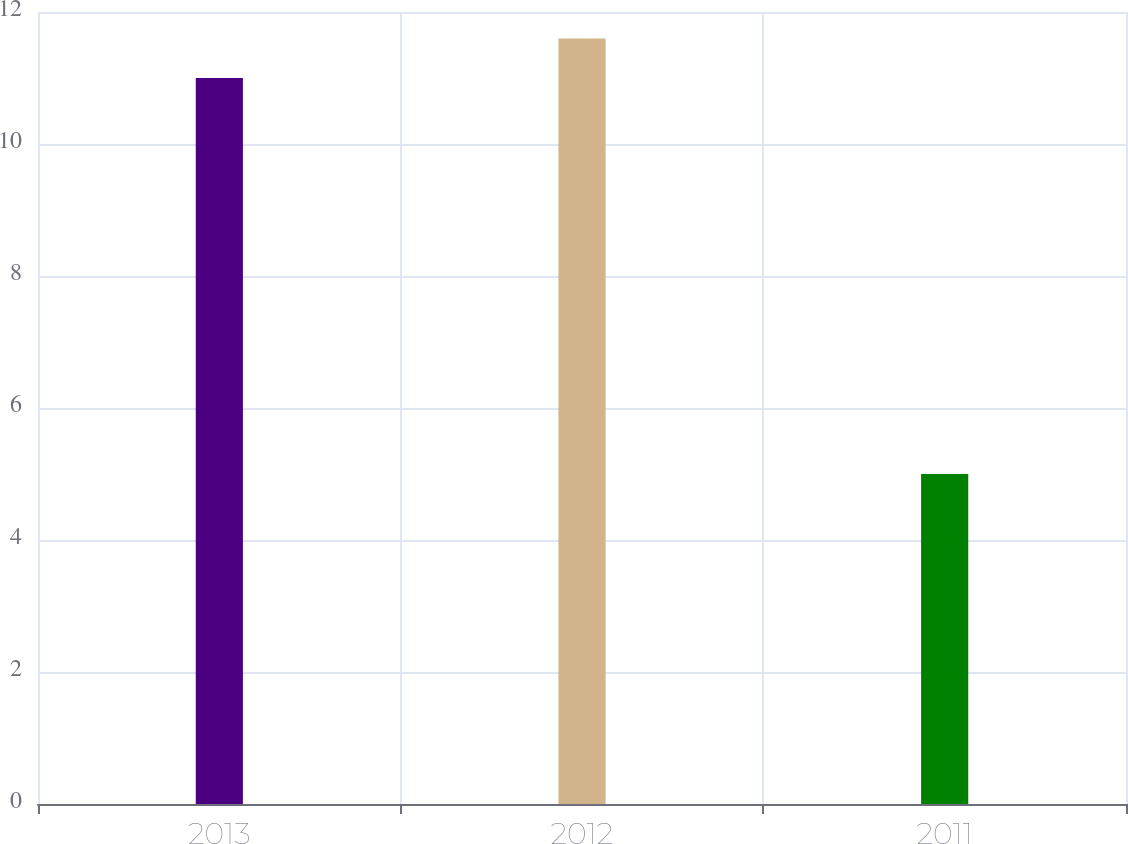Convert chart to OTSL. <chart><loc_0><loc_0><loc_500><loc_500><bar_chart><fcel>2013<fcel>2012<fcel>2011<nl><fcel>11<fcel>11.6<fcel>5<nl></chart> 